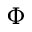<formula> <loc_0><loc_0><loc_500><loc_500>\Phi</formula> 